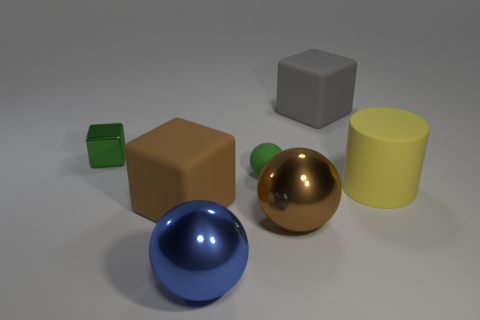Add 3 rubber balls. How many objects exist? 10 Subtract all green blocks. How many blocks are left? 2 Subtract all brown spheres. How many spheres are left? 2 Subtract 1 spheres. How many spheres are left? 2 Subtract 0 blue cylinders. How many objects are left? 7 Subtract all spheres. How many objects are left? 4 Subtract all gray blocks. Subtract all brown cylinders. How many blocks are left? 2 Subtract all blue cubes. How many brown spheres are left? 1 Subtract all large blue metallic balls. Subtract all small matte balls. How many objects are left? 5 Add 3 green matte things. How many green matte things are left? 4 